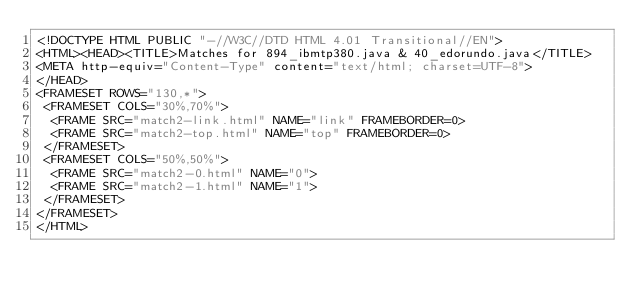Convert code to text. <code><loc_0><loc_0><loc_500><loc_500><_HTML_><!DOCTYPE HTML PUBLIC "-//W3C//DTD HTML 4.01 Transitional//EN">
<HTML><HEAD><TITLE>Matches for 894_ibmtp380.java & 40_edorundo.java</TITLE>
<META http-equiv="Content-Type" content="text/html; charset=UTF-8">
</HEAD>
<FRAMESET ROWS="130,*">
 <FRAMESET COLS="30%,70%">
  <FRAME SRC="match2-link.html" NAME="link" FRAMEBORDER=0>
  <FRAME SRC="match2-top.html" NAME="top" FRAMEBORDER=0>
 </FRAMESET>
 <FRAMESET COLS="50%,50%">
  <FRAME SRC="match2-0.html" NAME="0">
  <FRAME SRC="match2-1.html" NAME="1">
 </FRAMESET>
</FRAMESET>
</HTML>
</code> 